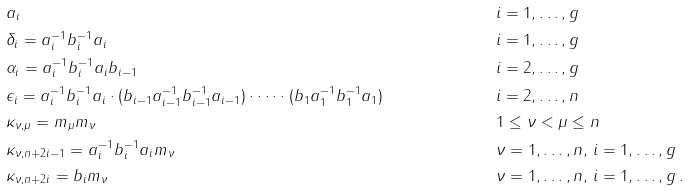Convert formula to latex. <formula><loc_0><loc_0><loc_500><loc_500>& a _ { i } & & i = 1 , \dots , g \\ & \delta _ { i } = a _ { i } ^ { - 1 } b _ { i } ^ { - 1 } a _ { i } & & i = 1 , \dots , g \\ & \alpha _ { i } = a _ { i } ^ { - 1 } b _ { i } ^ { - 1 } a _ { i } b _ { i - 1 } & & i = 2 , \dots , g \\ & \epsilon _ { i } = a _ { i } ^ { - 1 } b _ { i } ^ { - 1 } a _ { i } \cdot ( b _ { i - 1 } a ^ { - 1 } _ { i - 1 } b ^ { - 1 } _ { i - 1 } a _ { i - 1 } ) \cdot \dots \cdot ( b _ { 1 } a _ { 1 } ^ { - 1 } b _ { 1 } ^ { - 1 } a _ { 1 } ) & & i = 2 , \dots , n \\ & \kappa _ { \nu , \mu } = m _ { \mu } m _ { \nu } & & 1 \leq \nu < \mu \leq n \\ & \kappa _ { \nu , n + 2 i - 1 } = a _ { i } ^ { - 1 } b _ { i } ^ { - 1 } a _ { i } m _ { \nu } & & \nu = 1 , \dots , n , \, i = 1 , \dots , g \\ & \kappa _ { \nu , n + 2 i } = b _ { i } m _ { \nu } & & \nu = 1 , \dots , n , \, i = 1 , \dots , g \, .</formula> 